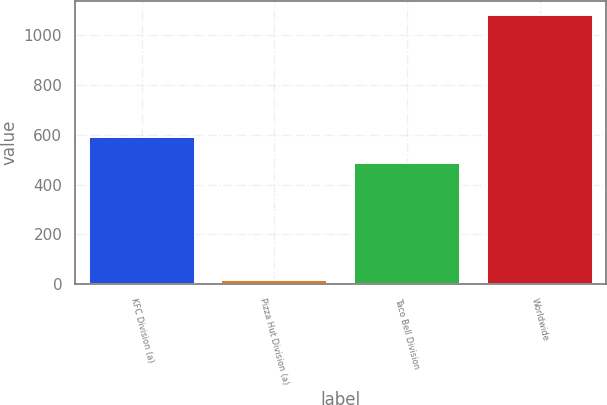Convert chart to OTSL. <chart><loc_0><loc_0><loc_500><loc_500><bar_chart><fcel>KFC Division (a)<fcel>Pizza Hut Division (a)<fcel>Taco Bell Division<fcel>Worldwide<nl><fcel>592.7<fcel>16<fcel>486<fcel>1083<nl></chart> 